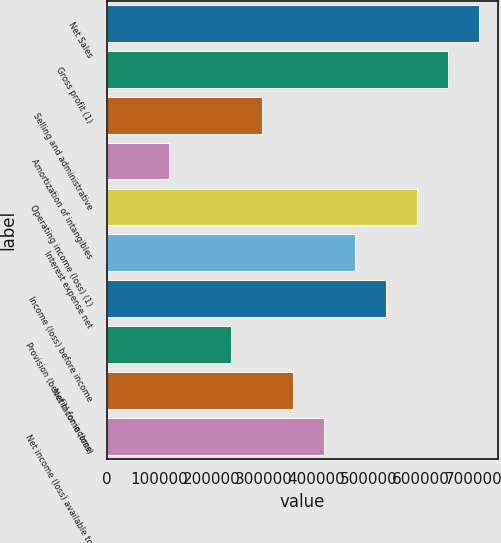Convert chart to OTSL. <chart><loc_0><loc_0><loc_500><loc_500><bar_chart><fcel>Net Sales<fcel>Gross profit (1)<fcel>Selling and administrative<fcel>Amortization of intangibles<fcel>Operating income (loss) (1)<fcel>Interest expense net<fcel>Income (loss) before income<fcel>Provision (benefit) for income<fcel>Net income (loss)<fcel>Net income (loss) available to<nl><fcel>711357<fcel>652078<fcel>296400<fcel>118561<fcel>592798<fcel>474239<fcel>533518<fcel>237120<fcel>355680<fcel>414959<nl></chart> 